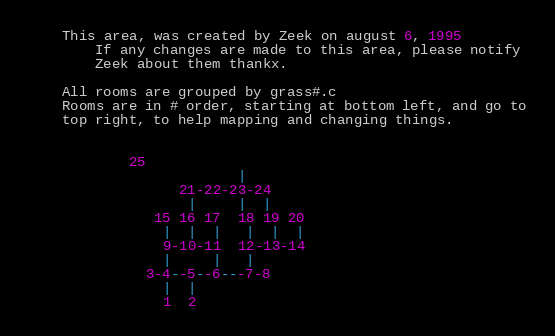<code> <loc_0><loc_0><loc_500><loc_500><_C_>
	This area, was created by Zeek on august 6, 1995
        If any changes are made to this area, please notify
        Zeek about them thankx.

	All rooms are grouped by grass#.c
	Rooms are in # order, starting at bottom left, and go to
	top right, to help mapping and changing things.


			25
                         |
                  21-22-23-24
                   |     |  |
               15 16 17  18 19 20
                |  |  |   |  |  |
                9-10-11  12-13-14
                |     |   |
              3-4--5--6---7-8
                |  |
                1  2
</code> 